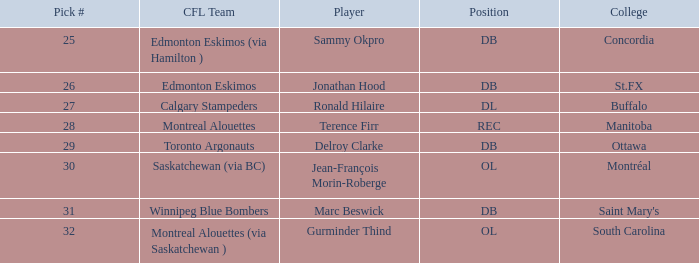Which cfl team possesses a pick # higher than 31? Montreal Alouettes (via Saskatchewan ). 